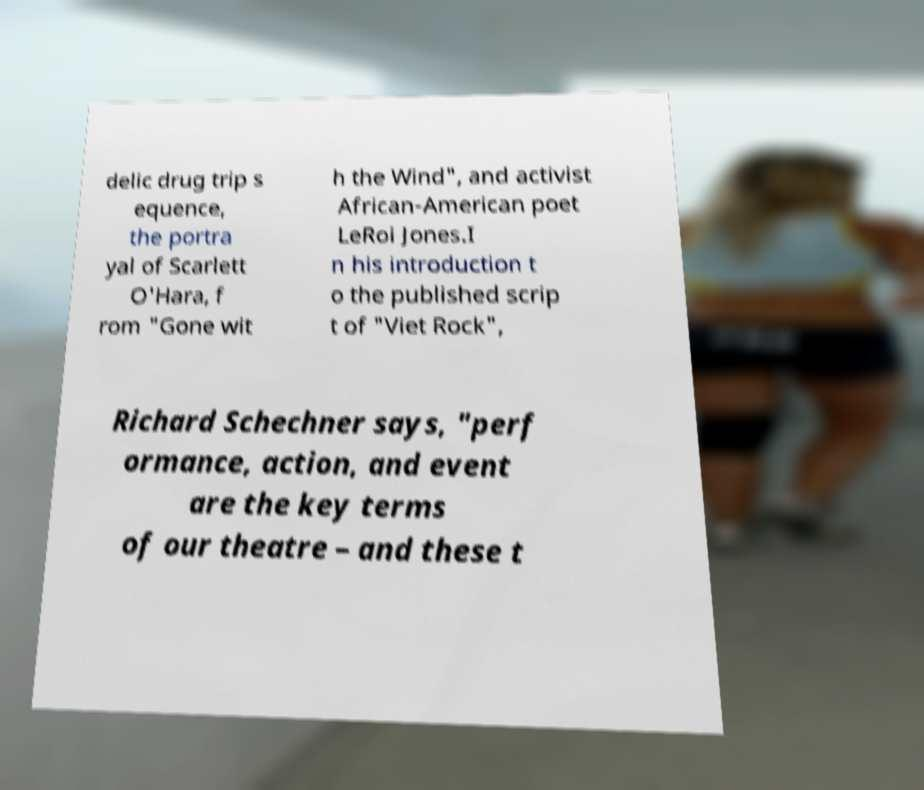Could you assist in decoding the text presented in this image and type it out clearly? delic drug trip s equence, the portra yal of Scarlett O'Hara, f rom "Gone wit h the Wind", and activist African-American poet LeRoi Jones.I n his introduction t o the published scrip t of "Viet Rock", Richard Schechner says, "perf ormance, action, and event are the key terms of our theatre – and these t 